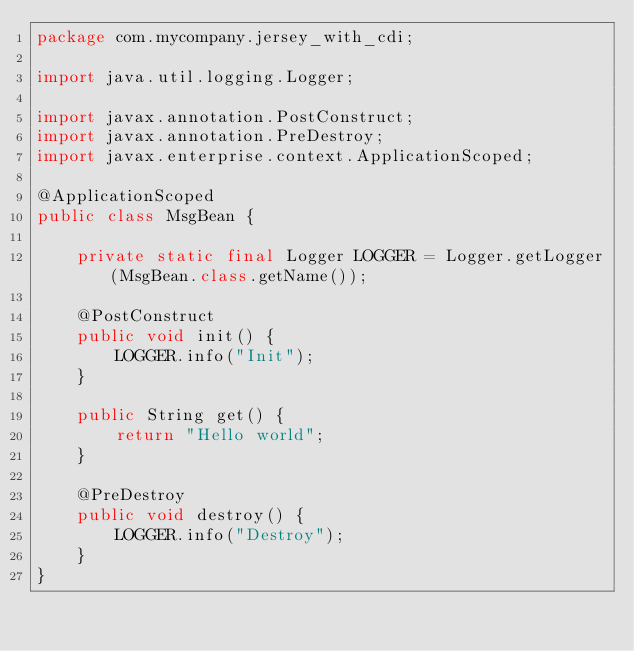<code> <loc_0><loc_0><loc_500><loc_500><_Java_>package com.mycompany.jersey_with_cdi;

import java.util.logging.Logger;

import javax.annotation.PostConstruct;
import javax.annotation.PreDestroy;
import javax.enterprise.context.ApplicationScoped;

@ApplicationScoped
public class MsgBean {

	private static final Logger LOGGER = Logger.getLogger(MsgBean.class.getName());

	@PostConstruct
	public void init() {
		LOGGER.info("Init");
	}

	public String get() {
		return "Hello world";
	}

	@PreDestroy
	public void destroy() {
		LOGGER.info("Destroy");
	}
}
</code> 